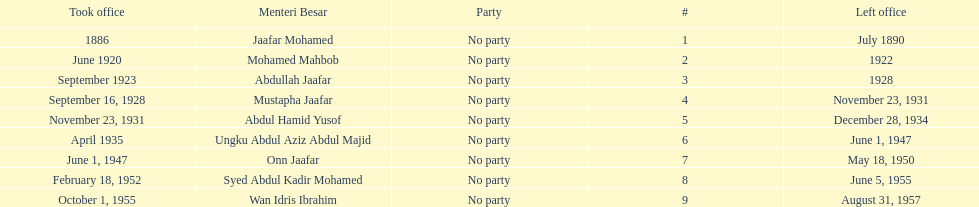Other than abullah jaafar, name someone with the same last name. Mustapha Jaafar. 